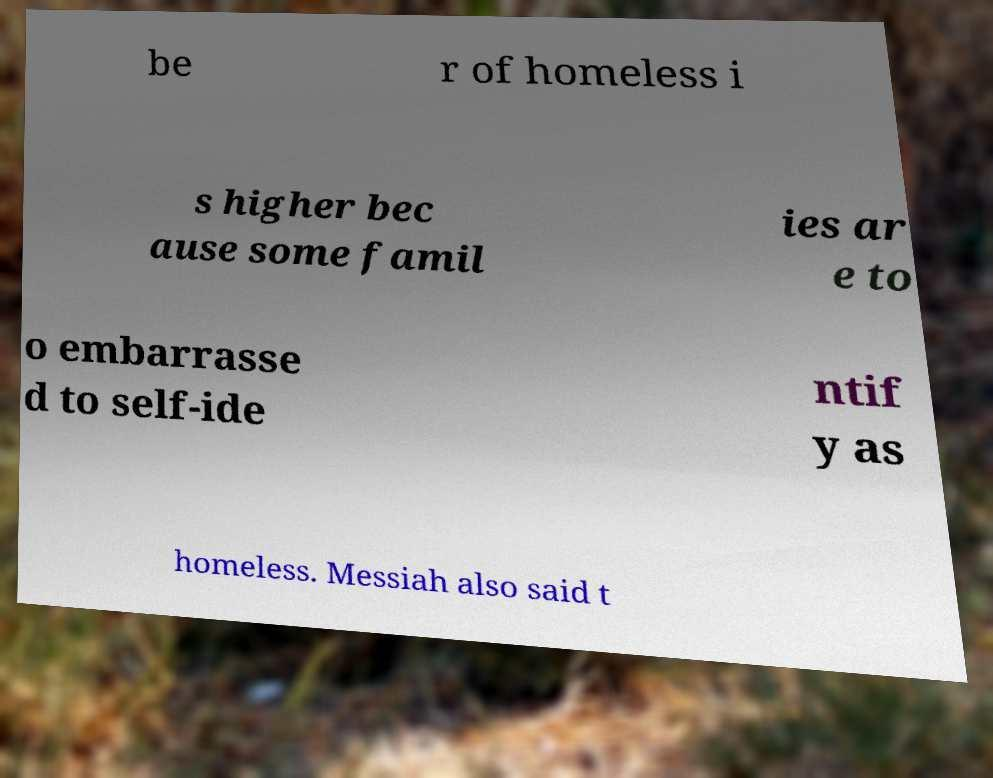Can you accurately transcribe the text from the provided image for me? be r of homeless i s higher bec ause some famil ies ar e to o embarrasse d to self-ide ntif y as homeless. Messiah also said t 